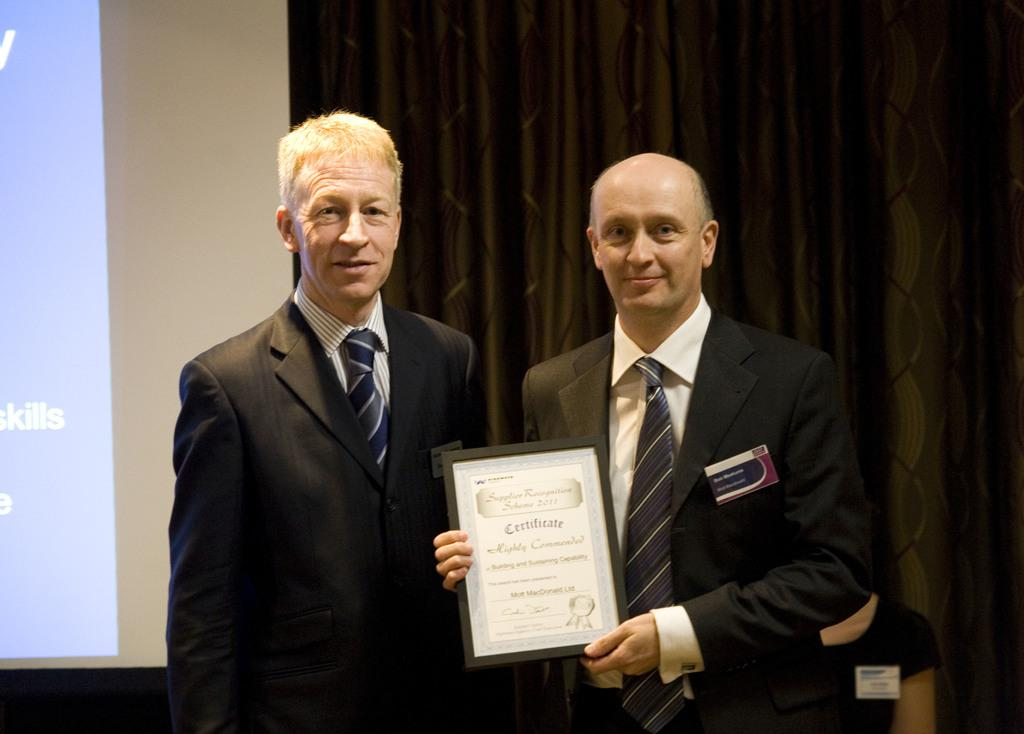How many people are in the image? There are three persons in the image. What is one of the persons holding? One of the persons is holding a certificate frame. What type of covering is present in the image? There is a curtain in the image. What can be seen on the screen in the image? There is a screen with text in the image. Is there a bed in the image? No, there is no bed present in the image. What type of calculator is being used by one of the persons in the image? There is no calculator visible in the image; only a certificate frame, curtain, and screen with text are present. 